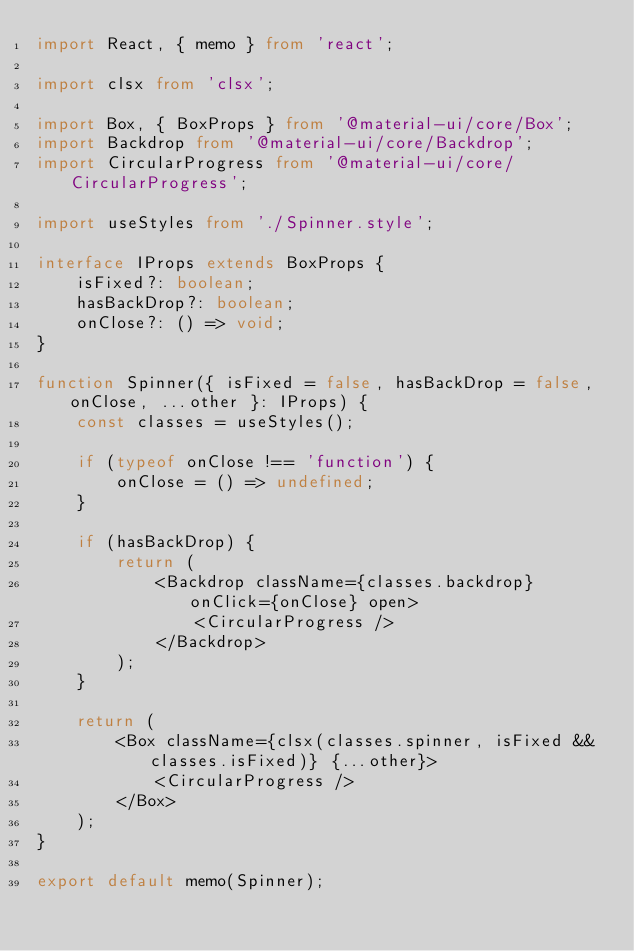Convert code to text. <code><loc_0><loc_0><loc_500><loc_500><_TypeScript_>import React, { memo } from 'react';

import clsx from 'clsx';

import Box, { BoxProps } from '@material-ui/core/Box';
import Backdrop from '@material-ui/core/Backdrop';
import CircularProgress from '@material-ui/core/CircularProgress';

import useStyles from './Spinner.style';

interface IProps extends BoxProps {
    isFixed?: boolean;
    hasBackDrop?: boolean;
    onClose?: () => void;
}

function Spinner({ isFixed = false, hasBackDrop = false, onClose, ...other }: IProps) {
    const classes = useStyles();

    if (typeof onClose !== 'function') {
        onClose = () => undefined;
    }

    if (hasBackDrop) {
        return (
            <Backdrop className={classes.backdrop} onClick={onClose} open>
                <CircularProgress />
            </Backdrop>
        );
    }

    return (
        <Box className={clsx(classes.spinner, isFixed && classes.isFixed)} {...other}>
            <CircularProgress />
        </Box>
    );
}

export default memo(Spinner);
</code> 